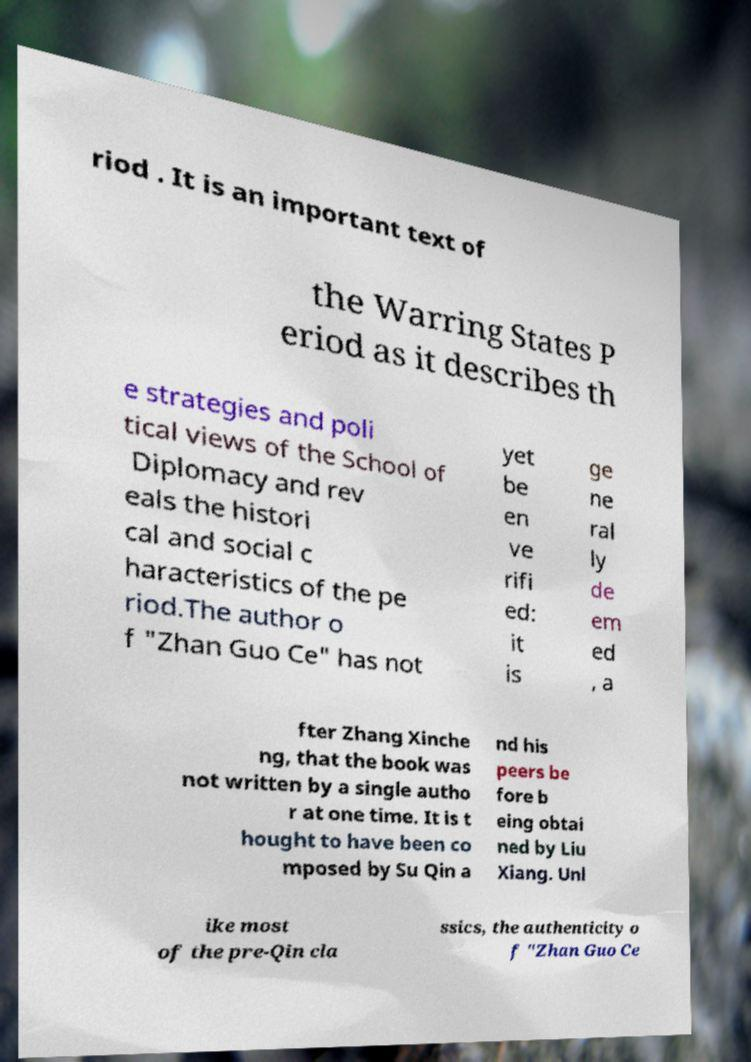Please identify and transcribe the text found in this image. riod . It is an important text of the Warring States P eriod as it describes th e strategies and poli tical views of the School of Diplomacy and rev eals the histori cal and social c haracteristics of the pe riod.The author o f "Zhan Guo Ce" has not yet be en ve rifi ed: it is ge ne ral ly de em ed , a fter Zhang Xinche ng, that the book was not written by a single autho r at one time. It is t hought to have been co mposed by Su Qin a nd his peers be fore b eing obtai ned by Liu Xiang. Unl ike most of the pre-Qin cla ssics, the authenticity o f "Zhan Guo Ce 